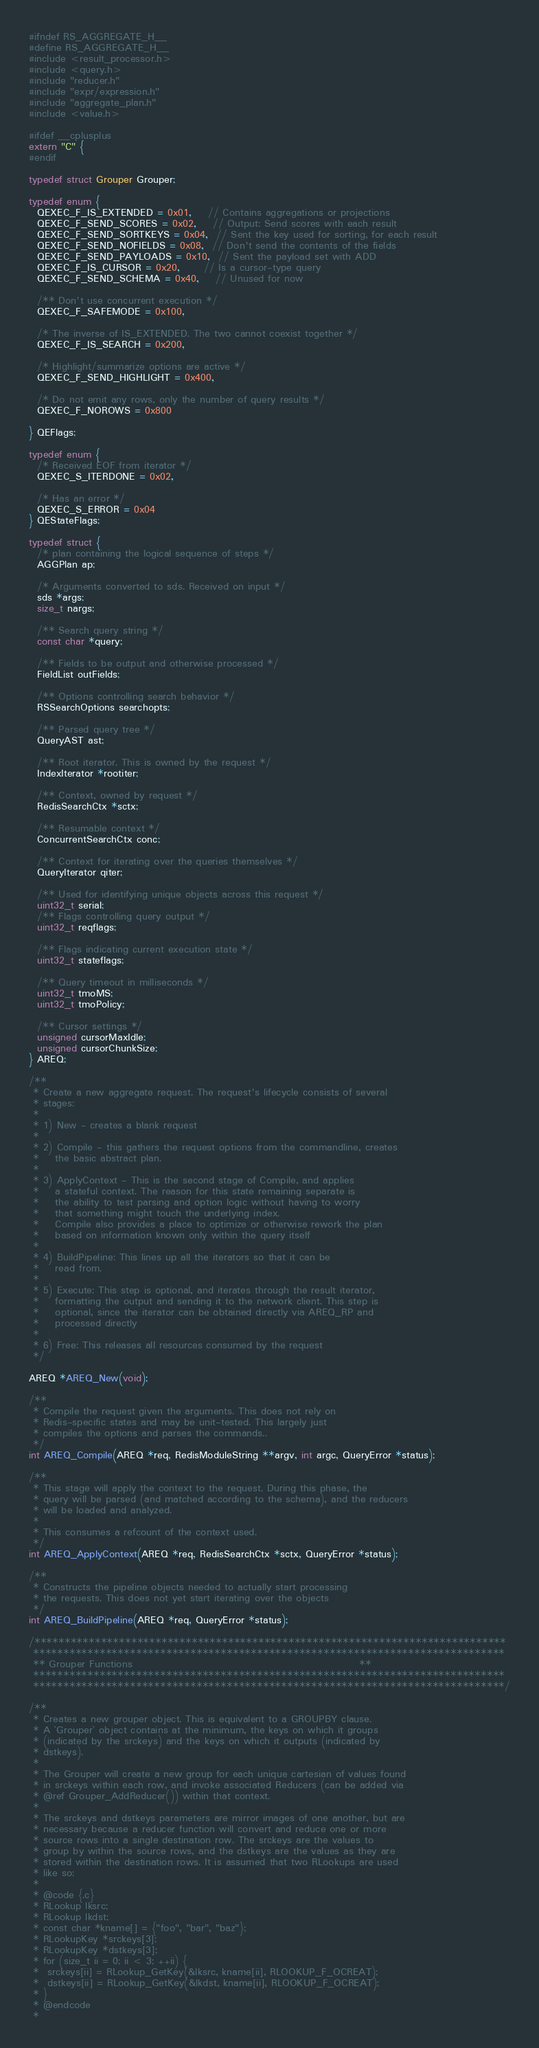Convert code to text. <code><loc_0><loc_0><loc_500><loc_500><_C_>#ifndef RS_AGGREGATE_H__
#define RS_AGGREGATE_H__
#include <result_processor.h>
#include <query.h>
#include "reducer.h"
#include "expr/expression.h"
#include "aggregate_plan.h"
#include <value.h>

#ifdef __cplusplus
extern "C" {
#endif

typedef struct Grouper Grouper;

typedef enum {
  QEXEC_F_IS_EXTENDED = 0x01,    // Contains aggregations or projections
  QEXEC_F_SEND_SCORES = 0x02,    // Output: Send scores with each result
  QEXEC_F_SEND_SORTKEYS = 0x04,  // Sent the key used for sorting, for each result
  QEXEC_F_SEND_NOFIELDS = 0x08,  // Don't send the contents of the fields
  QEXEC_F_SEND_PAYLOADS = 0x10,  // Sent the payload set with ADD
  QEXEC_F_IS_CURSOR = 0x20,      // Is a cursor-type query
  QEXEC_F_SEND_SCHEMA = 0x40,    // Unused for now

  /** Don't use concurrent execution */
  QEXEC_F_SAFEMODE = 0x100,

  /* The inverse of IS_EXTENDED. The two cannot coexist together */
  QEXEC_F_IS_SEARCH = 0x200,

  /* Highlight/summarize options are active */
  QEXEC_F_SEND_HIGHLIGHT = 0x400,

  /* Do not emit any rows, only the number of query results */
  QEXEC_F_NOROWS = 0x800

} QEFlags;

typedef enum {
  /* Received EOF from iterator */
  QEXEC_S_ITERDONE = 0x02,

  /* Has an error */
  QEXEC_S_ERROR = 0x04
} QEStateFlags;

typedef struct {
  /* plan containing the logical sequence of steps */
  AGGPlan ap;

  /* Arguments converted to sds. Received on input */
  sds *args;
  size_t nargs;

  /** Search query string */
  const char *query;

  /** Fields to be output and otherwise processed */
  FieldList outFields;

  /** Options controlling search behavior */
  RSSearchOptions searchopts;

  /** Parsed query tree */
  QueryAST ast;

  /** Root iterator. This is owned by the request */
  IndexIterator *rootiter;

  /** Context, owned by request */
  RedisSearchCtx *sctx;

  /** Resumable context */
  ConcurrentSearchCtx conc;

  /** Context for iterating over the queries themselves */
  QueryIterator qiter;

  /** Used for identifying unique objects across this request */
  uint32_t serial;
  /** Flags controlling query output */
  uint32_t reqflags;

  /** Flags indicating current execution state */
  uint32_t stateflags;

  /** Query timeout in milliseconds */
  uint32_t tmoMS;
  uint32_t tmoPolicy;

  /** Cursor settings */
  unsigned cursorMaxIdle;
  unsigned cursorChunkSize;
} AREQ;

/**
 * Create a new aggregate request. The request's lifecycle consists of several
 * stages:
 *
 * 1) New - creates a blank request
 *
 * 2) Compile - this gathers the request options from the commandline, creates
 *    the basic abstract plan.
 *
 * 3) ApplyContext - This is the second stage of Compile, and applies
 *    a stateful context. The reason for this state remaining separate is
 *    the ability to test parsing and option logic without having to worry
 *    that something might touch the underlying index.
 *    Compile also provides a place to optimize or otherwise rework the plan
 *    based on information known only within the query itself
 *
 * 4) BuildPipeline: This lines up all the iterators so that it can be
 *    read from.
 *
 * 5) Execute: This step is optional, and iterates through the result iterator,
 *    formatting the output and sending it to the network client. This step is
 *    optional, since the iterator can be obtained directly via AREQ_RP and
 *    processed directly
 *
 * 6) Free: This releases all resources consumed by the request
 */

AREQ *AREQ_New(void);

/**
 * Compile the request given the arguments. This does not rely on
 * Redis-specific states and may be unit-tested. This largely just
 * compiles the options and parses the commands..
 */
int AREQ_Compile(AREQ *req, RedisModuleString **argv, int argc, QueryError *status);

/**
 * This stage will apply the context to the request. During this phase, the
 * query will be parsed (and matched according to the schema), and the reducers
 * will be loaded and analyzed.
 *
 * This consumes a refcount of the context used.
 */
int AREQ_ApplyContext(AREQ *req, RedisSearchCtx *sctx, QueryError *status);

/**
 * Constructs the pipeline objects needed to actually start processing
 * the requests. This does not yet start iterating over the objects
 */
int AREQ_BuildPipeline(AREQ *req, QueryError *status);

/******************************************************************************
 ******************************************************************************
 ** Grouper Functions                                                        **
 ******************************************************************************
 ******************************************************************************/

/**
 * Creates a new grouper object. This is equivalent to a GROUPBY clause.
 * A `Grouper` object contains at the minimum, the keys on which it groups
 * (indicated by the srckeys) and the keys on which it outputs (indicated by
 * dstkeys).
 *
 * The Grouper will create a new group for each unique cartesian of values found
 * in srckeys within each row, and invoke associated Reducers (can be added via
 * @ref Grouper_AddReducer()) within that context.
 *
 * The srckeys and dstkeys parameters are mirror images of one another, but are
 * necessary because a reducer function will convert and reduce one or more
 * source rows into a single destination row. The srckeys are the values to
 * group by within the source rows, and the dstkeys are the values as they are
 * stored within the destination rows. It is assumed that two RLookups are used
 * like so:
 *
 * @code {.c}
 * RLookup lksrc;
 * RLookup lkdst;
 * const char *kname[] = {"foo", "bar", "baz"};
 * RLookupKey *srckeys[3];
 * RLookupKey *dstkeys[3];
 * for (size_t ii = 0; ii < 3; ++ii) {
 *  srckeys[ii] = RLookup_GetKey(&lksrc, kname[ii], RLOOKUP_F_OCREAT);
 *  dstkeys[ii] = RLookup_GetKey(&lkdst, kname[ii], RLOOKUP_F_OCREAT);
 * }
 * @endcode
 *</code> 